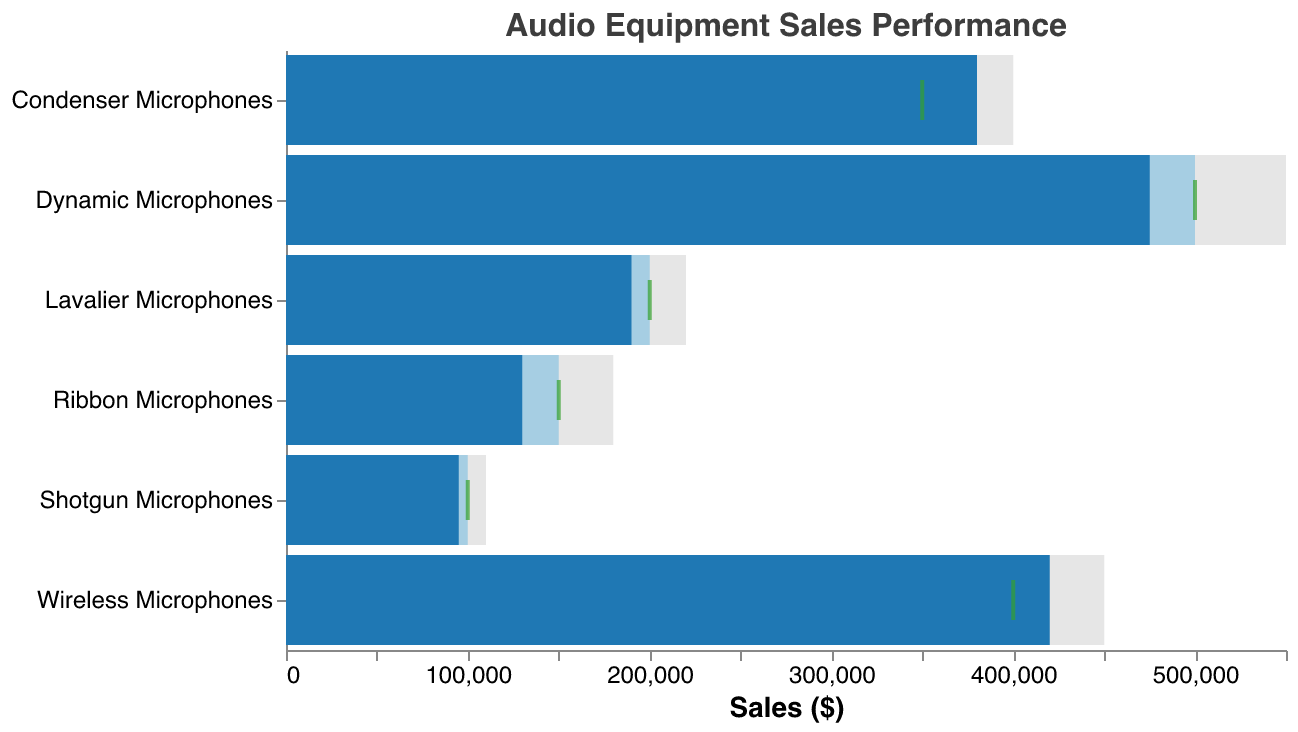What's the title of the chart? The title is displayed at the top and reads "Audio Equipment Sales Performance."
Answer: Audio Equipment Sales Performance How many types of microphones are represented in the chart? The y-axis lists the different types of microphones, which total to six kinds.
Answer: Six What color represents the actual sales of microphones? The bars representing actual sales are colored in a blue shade.
Answer: Blue Which type of microphone had the highest actual sales? By comparing the blue bars for each type of microphone, the Wireless Microphones have the highest actual sales value.
Answer: Wireless Microphones Which type of microphone had actual sales below its sales target? Observing the blue and cyan bars, Dynamic Microphones, Ribbon Microphones, Lavalier Microphones, and Shotgun Microphones all had actual sales below their targets.
Answer: Dynamic Microphones, Ribbon Microphones, Lavalier Microphones, Shotgun Microphones What is the difference between the sales target and actual sales for Ribbon Microphones? Subtract the actual sales (130000) from the sales target (150000): 150000 - 130000 = 20000.
Answer: 20000 What proportion of the sales target did Wireless Microphones achieve in actual sales? The actual sales (420000) are divided by the sales target (400000): 420000 / 400000 = 1.05, or 105%.
Answer: 105% Which microphone type had the smallest gap between its comparative measure and actual sales? By examining the length of the gray bars and the blue bars, Condenser Microphones had the smallest gap: 400000 (comparative measure) - 380000 (actual sales) = 20000.
Answer: Condenser Microphones Across all microphone types, what is the total actual sales amount? Summing the actual sales for all types: 475000 + 380000 + 130000 + 420000 + 190000 + 95000 = 1690000.
Answer: 1690000 How does the comparative measure generally compare to the sales targets? In general, the comparative measure displayed by gray bars is higher than the sales targets for all microphone types, indicating a higher benchmark.
Answer: Higher 